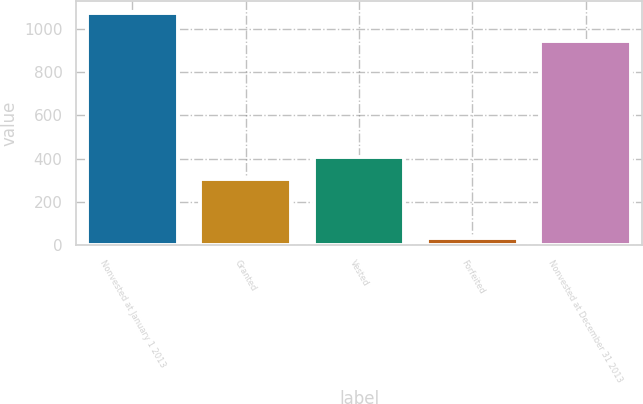Convert chart to OTSL. <chart><loc_0><loc_0><loc_500><loc_500><bar_chart><fcel>Nonvested at January 1 2013<fcel>Granted<fcel>Vested<fcel>Forfeited<fcel>Nonvested at December 31 2013<nl><fcel>1075<fcel>304<fcel>408.1<fcel>34<fcel>944<nl></chart> 